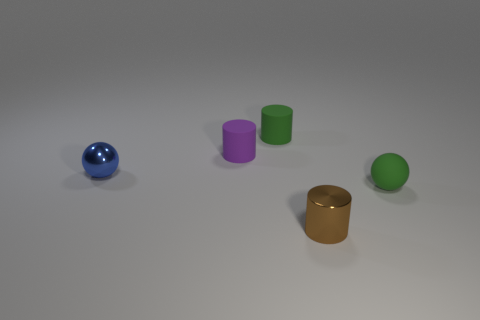There is a tiny cylinder that is left of the small green rubber cylinder; what number of small spheres are right of it?
Provide a short and direct response. 1. Are there any brown things of the same shape as the small purple object?
Give a very brief answer. Yes. There is a matte object right of the green cylinder; does it have the same shape as the object behind the purple matte cylinder?
Make the answer very short. No. The thing that is both on the right side of the green rubber cylinder and behind the tiny metallic cylinder has what shape?
Provide a succinct answer. Sphere. Is there a gray matte cylinder of the same size as the blue sphere?
Keep it short and to the point. No. There is a metallic cylinder; is it the same color as the matte thing right of the green matte cylinder?
Your response must be concise. No. What material is the tiny purple object?
Offer a terse response. Rubber. What color is the metallic thing that is on the right side of the blue ball?
Give a very brief answer. Brown. How many tiny matte spheres are the same color as the metal ball?
Ensure brevity in your answer.  0. What number of tiny things are both on the left side of the purple rubber cylinder and to the right of the tiny blue shiny object?
Offer a very short reply. 0. 